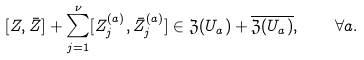Convert formula to latex. <formula><loc_0><loc_0><loc_500><loc_500>[ Z , \bar { Z } ] + \sum _ { j = 1 } ^ { \nu } [ Z ^ { ( a ) } _ { j } , \bar { Z } ^ { ( a ) } _ { j } ] \in \mathfrak { Z } ( U _ { a } ) + \overline { \mathfrak { Z } ( U _ { a } ) } , \quad \forall a .</formula> 